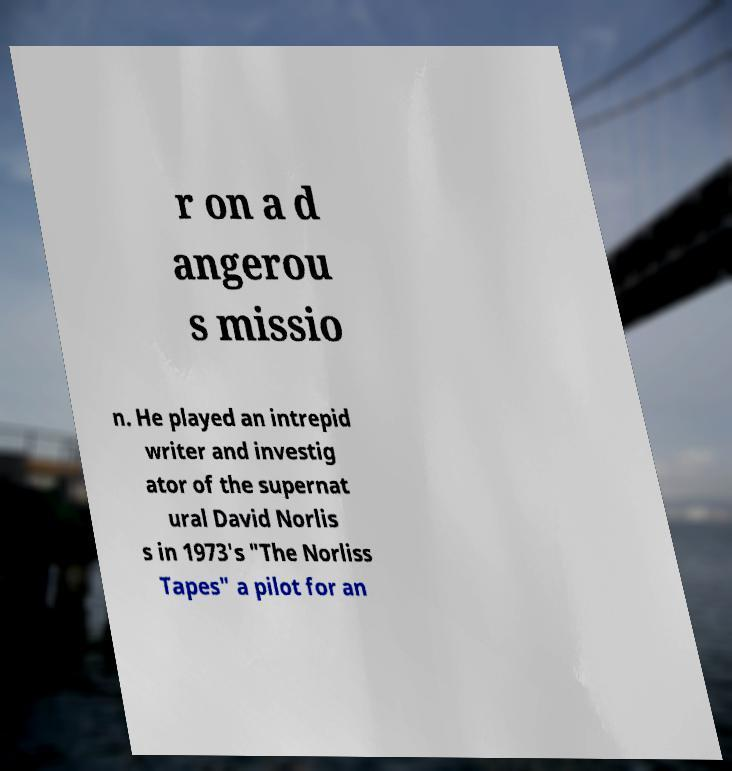Can you read and provide the text displayed in the image?This photo seems to have some interesting text. Can you extract and type it out for me? r on a d angerou s missio n. He played an intrepid writer and investig ator of the supernat ural David Norlis s in 1973's "The Norliss Tapes" a pilot for an 